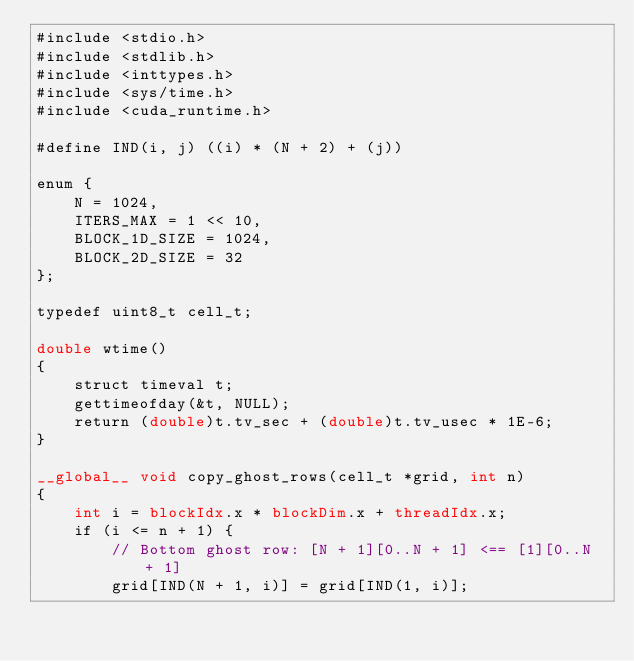Convert code to text. <code><loc_0><loc_0><loc_500><loc_500><_Cuda_>#include <stdio.h>
#include <stdlib.h>
#include <inttypes.h>
#include <sys/time.h>
#include <cuda_runtime.h>

#define IND(i, j) ((i) * (N + 2) + (j))

enum {
    N = 1024,
    ITERS_MAX = 1 << 10,
    BLOCK_1D_SIZE = 1024,
    BLOCK_2D_SIZE = 32
};

typedef uint8_t cell_t;

double wtime()
{
    struct timeval t;
    gettimeofday(&t, NULL);
    return (double)t.tv_sec + (double)t.tv_usec * 1E-6;
}

__global__ void copy_ghost_rows(cell_t *grid, int n)
{
    int i = blockIdx.x * blockDim.x + threadIdx.x;
    if (i <= n + 1) {
        // Bottom ghost row: [N + 1][0..N + 1] <== [1][0..N + 1]
        grid[IND(N + 1, i)] = grid[IND(1, i)];</code> 